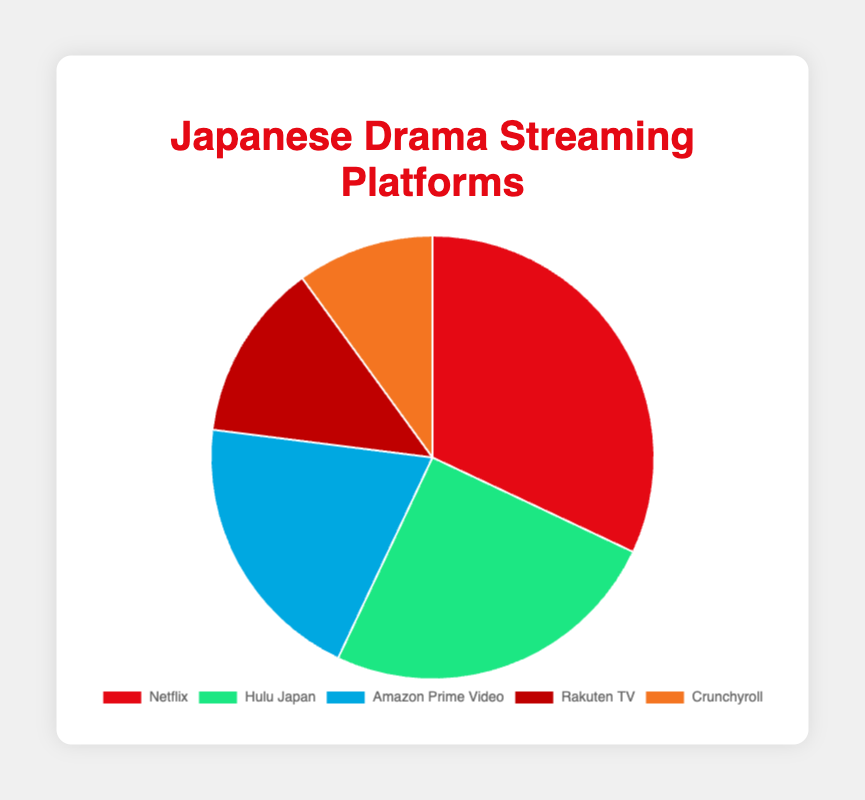Which platform has the highest percentage of users? The largest slice of the pie chart is labeled "Netflix," which shows it has the highest percentage of users.
Answer: Netflix Which platform has the smallest share of users? The smallest slice of the pie chart is labeled "Crunchyroll," which shows it has the smallest share of users.
Answer: Crunchyroll What's the combined percentage of users for Hulu Japan and Amazon Prime Video? Add the percentages for Hulu Japan (25%) and Amazon Prime Video (20%): 25% + 20% = 45%.
Answer: 45% Compare the shares of Netflix and Rakuten TV. How much larger is Netflix's share? Netflix's share is 32%, and Rakuten TV's is 13%. Subtract Rakuten TV's share from Netflix's: 32% - 13% = 19%.
Answer: 19% Which platform has a green-colored slice in the pie chart? The green-colored slice corresponds to the label "Hulu Japan," which has a 25% share.
Answer: Hulu Japan What's the sum of the percentages for all platforms except Netflix? Add the percentages for Hulu Japan (25%), Amazon Prime Video (20%), Rakuten TV (13%), and Crunchyroll (10%): 25% + 20% + 13% + 10% = 68%.
Answer: 68% Is the user share for Amazon Prime Video greater than that for Rakuten TV and Crunchyroll combined? Add the percentages for Rakuten TV (13%) and Crunchyroll (10%): 13% + 10% = 23%. Compare it with Amazon Prime Video's 20%. Since 20% < 23%, Amazon Prime Video's share is not greater.
Answer: No If the percentages for Rakuten TV and Crunchyroll were combined, would their total be more or less than Hulu Japan's share? Add the percentages for Rakuten TV (13%) and Crunchyroll (10%): 13% + 10% = 23%. Compare it with Hulu Japan's 25%. Since 23% < 25%, their combined share would be less than Hulu Japan's share.
Answer: Less Rank the platforms from highest to lowest in terms of user share. Order the platforms by their given percentages: Netflix (32%), Hulu Japan (25%), Amazon Prime Video (20%), Rakuten TV (13%), Crunchyroll (10%).
Answer: Netflix > Hulu Japan > Amazon Prime Video > Rakuten TV > Crunchyroll 